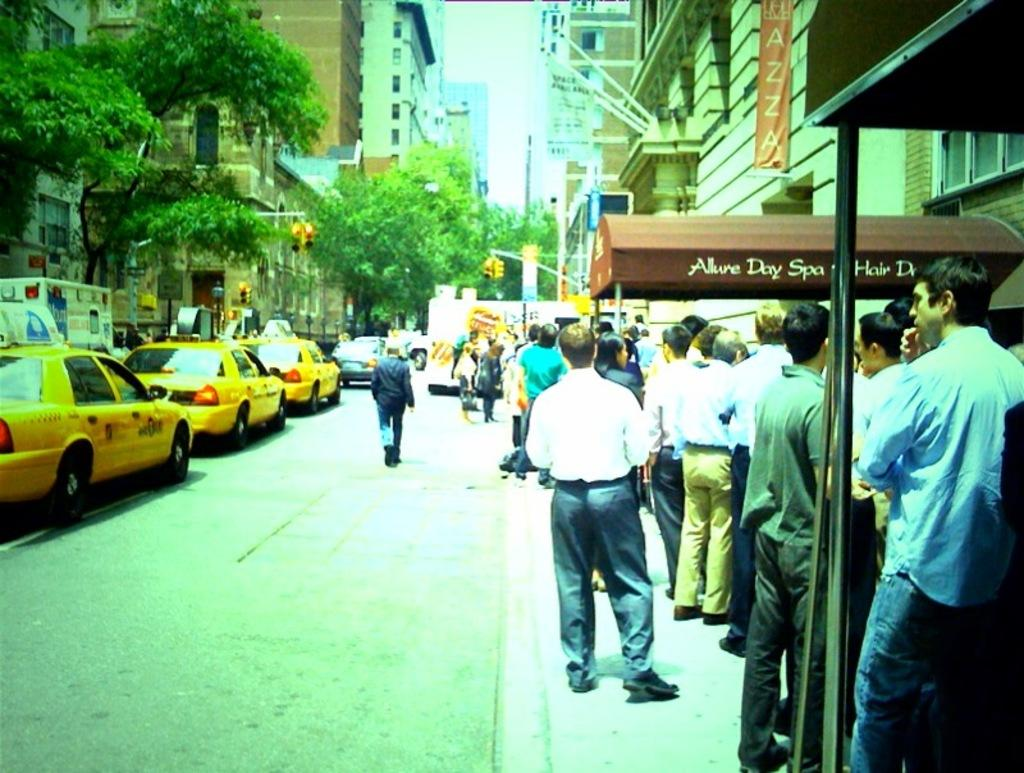<image>
Present a compact description of the photo's key features. a group of people outside of a building with the word hair on it 